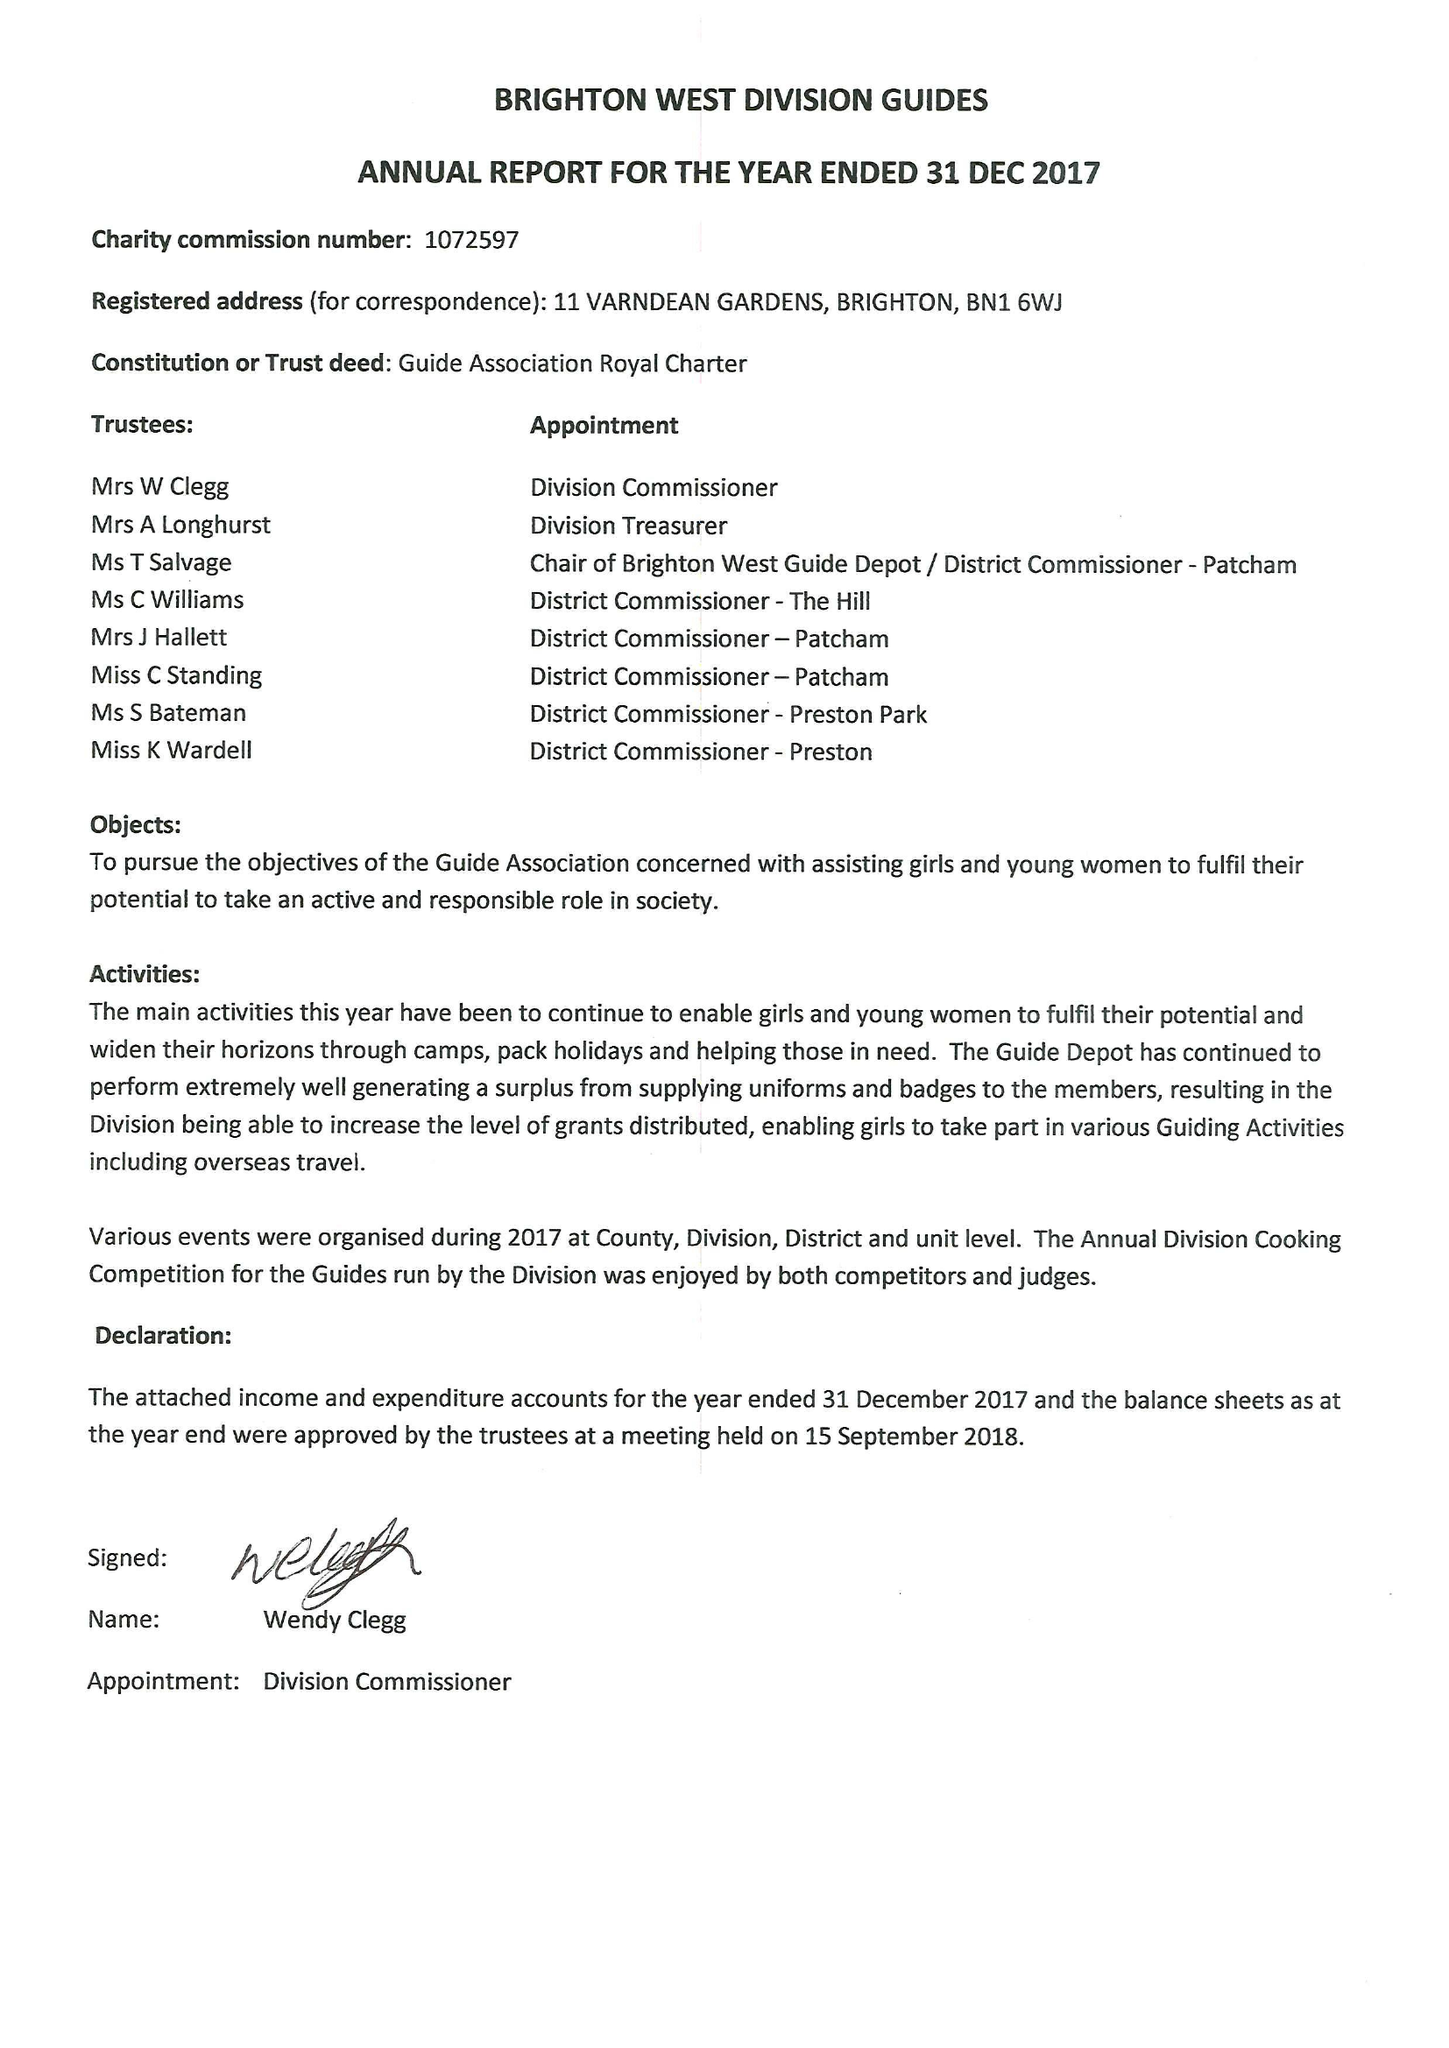What is the value for the address__street_line?
Answer the question using a single word or phrase. 11 VARNDEAN GARDENS 